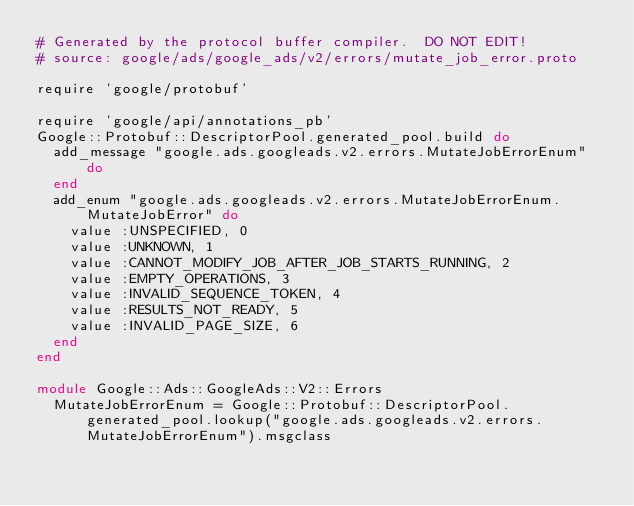<code> <loc_0><loc_0><loc_500><loc_500><_Ruby_># Generated by the protocol buffer compiler.  DO NOT EDIT!
# source: google/ads/google_ads/v2/errors/mutate_job_error.proto

require 'google/protobuf'

require 'google/api/annotations_pb'
Google::Protobuf::DescriptorPool.generated_pool.build do
  add_message "google.ads.googleads.v2.errors.MutateJobErrorEnum" do
  end
  add_enum "google.ads.googleads.v2.errors.MutateJobErrorEnum.MutateJobError" do
    value :UNSPECIFIED, 0
    value :UNKNOWN, 1
    value :CANNOT_MODIFY_JOB_AFTER_JOB_STARTS_RUNNING, 2
    value :EMPTY_OPERATIONS, 3
    value :INVALID_SEQUENCE_TOKEN, 4
    value :RESULTS_NOT_READY, 5
    value :INVALID_PAGE_SIZE, 6
  end
end

module Google::Ads::GoogleAds::V2::Errors
  MutateJobErrorEnum = Google::Protobuf::DescriptorPool.generated_pool.lookup("google.ads.googleads.v2.errors.MutateJobErrorEnum").msgclass</code> 